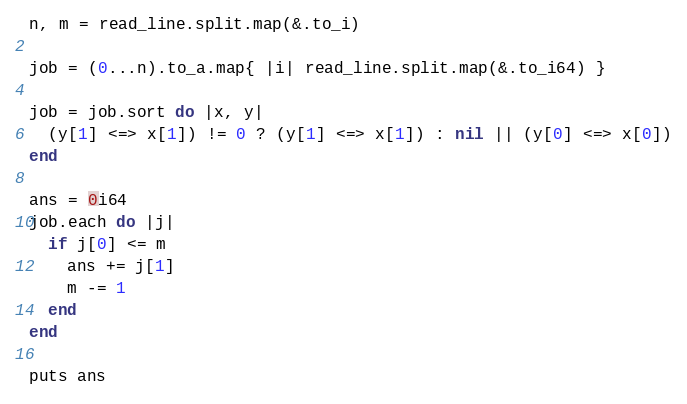Convert code to text. <code><loc_0><loc_0><loc_500><loc_500><_Crystal_>n, m = read_line.split.map(&.to_i)

job = (0...n).to_a.map{ |i| read_line.split.map(&.to_i64) }

job = job.sort do |x, y|
  (y[1] <=> x[1]) != 0 ? (y[1] <=> x[1]) : nil || (y[0] <=> x[0])
end

ans = 0i64
job.each do |j|
  if j[0] <= m
    ans += j[1]
    m -= 1
  end
end

puts ans</code> 